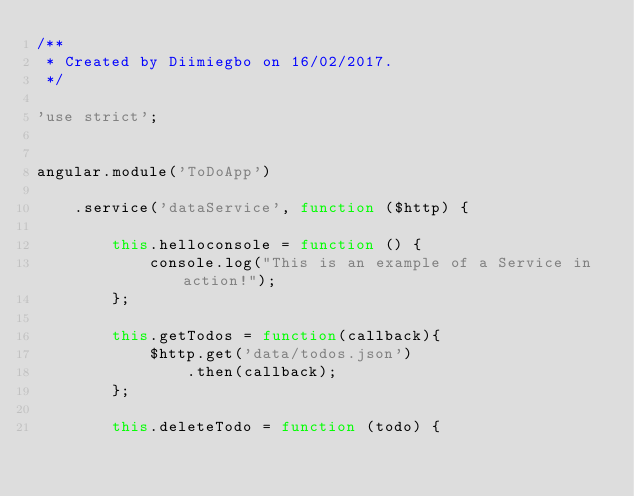Convert code to text. <code><loc_0><loc_0><loc_500><loc_500><_JavaScript_>/**
 * Created by Diimiegbo on 16/02/2017.
 */

'use strict';


angular.module('ToDoApp')

    .service('dataService', function ($http) {

        this.helloconsole = function () {
            console.log("This is an example of a Service in action!");
        };

        this.getTodos = function(callback){
            $http.get('data/todos.json')
                .then(callback);
        };

        this.deleteTodo = function (todo) {</code> 